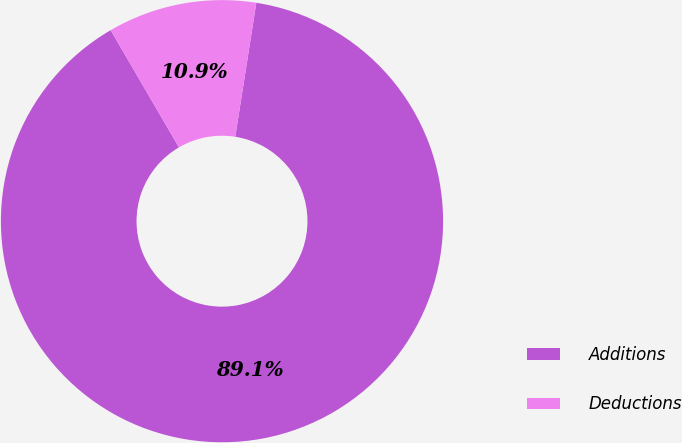Convert chart. <chart><loc_0><loc_0><loc_500><loc_500><pie_chart><fcel>Additions<fcel>Deductions<nl><fcel>89.12%<fcel>10.88%<nl></chart> 